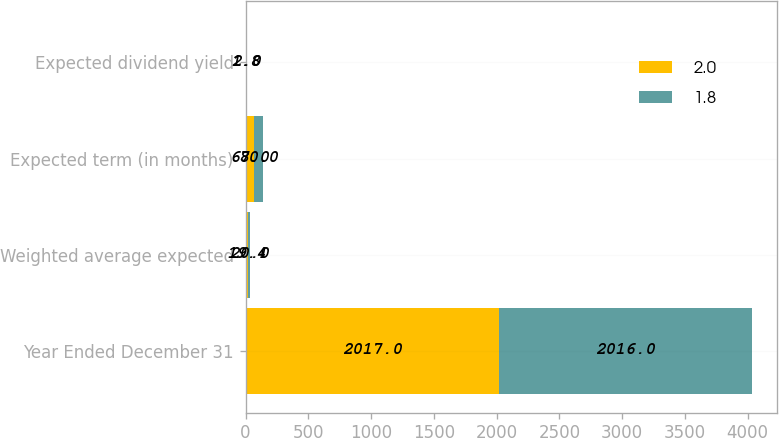Convert chart to OTSL. <chart><loc_0><loc_0><loc_500><loc_500><stacked_bar_chart><ecel><fcel>Year Ended December 31<fcel>Weighted average expected<fcel>Expected term (in months)<fcel>Expected dividend yield<nl><fcel>2<fcel>2017<fcel>19.4<fcel>68<fcel>1.8<nl><fcel>1.8<fcel>2016<fcel>20<fcel>70<fcel>2<nl></chart> 